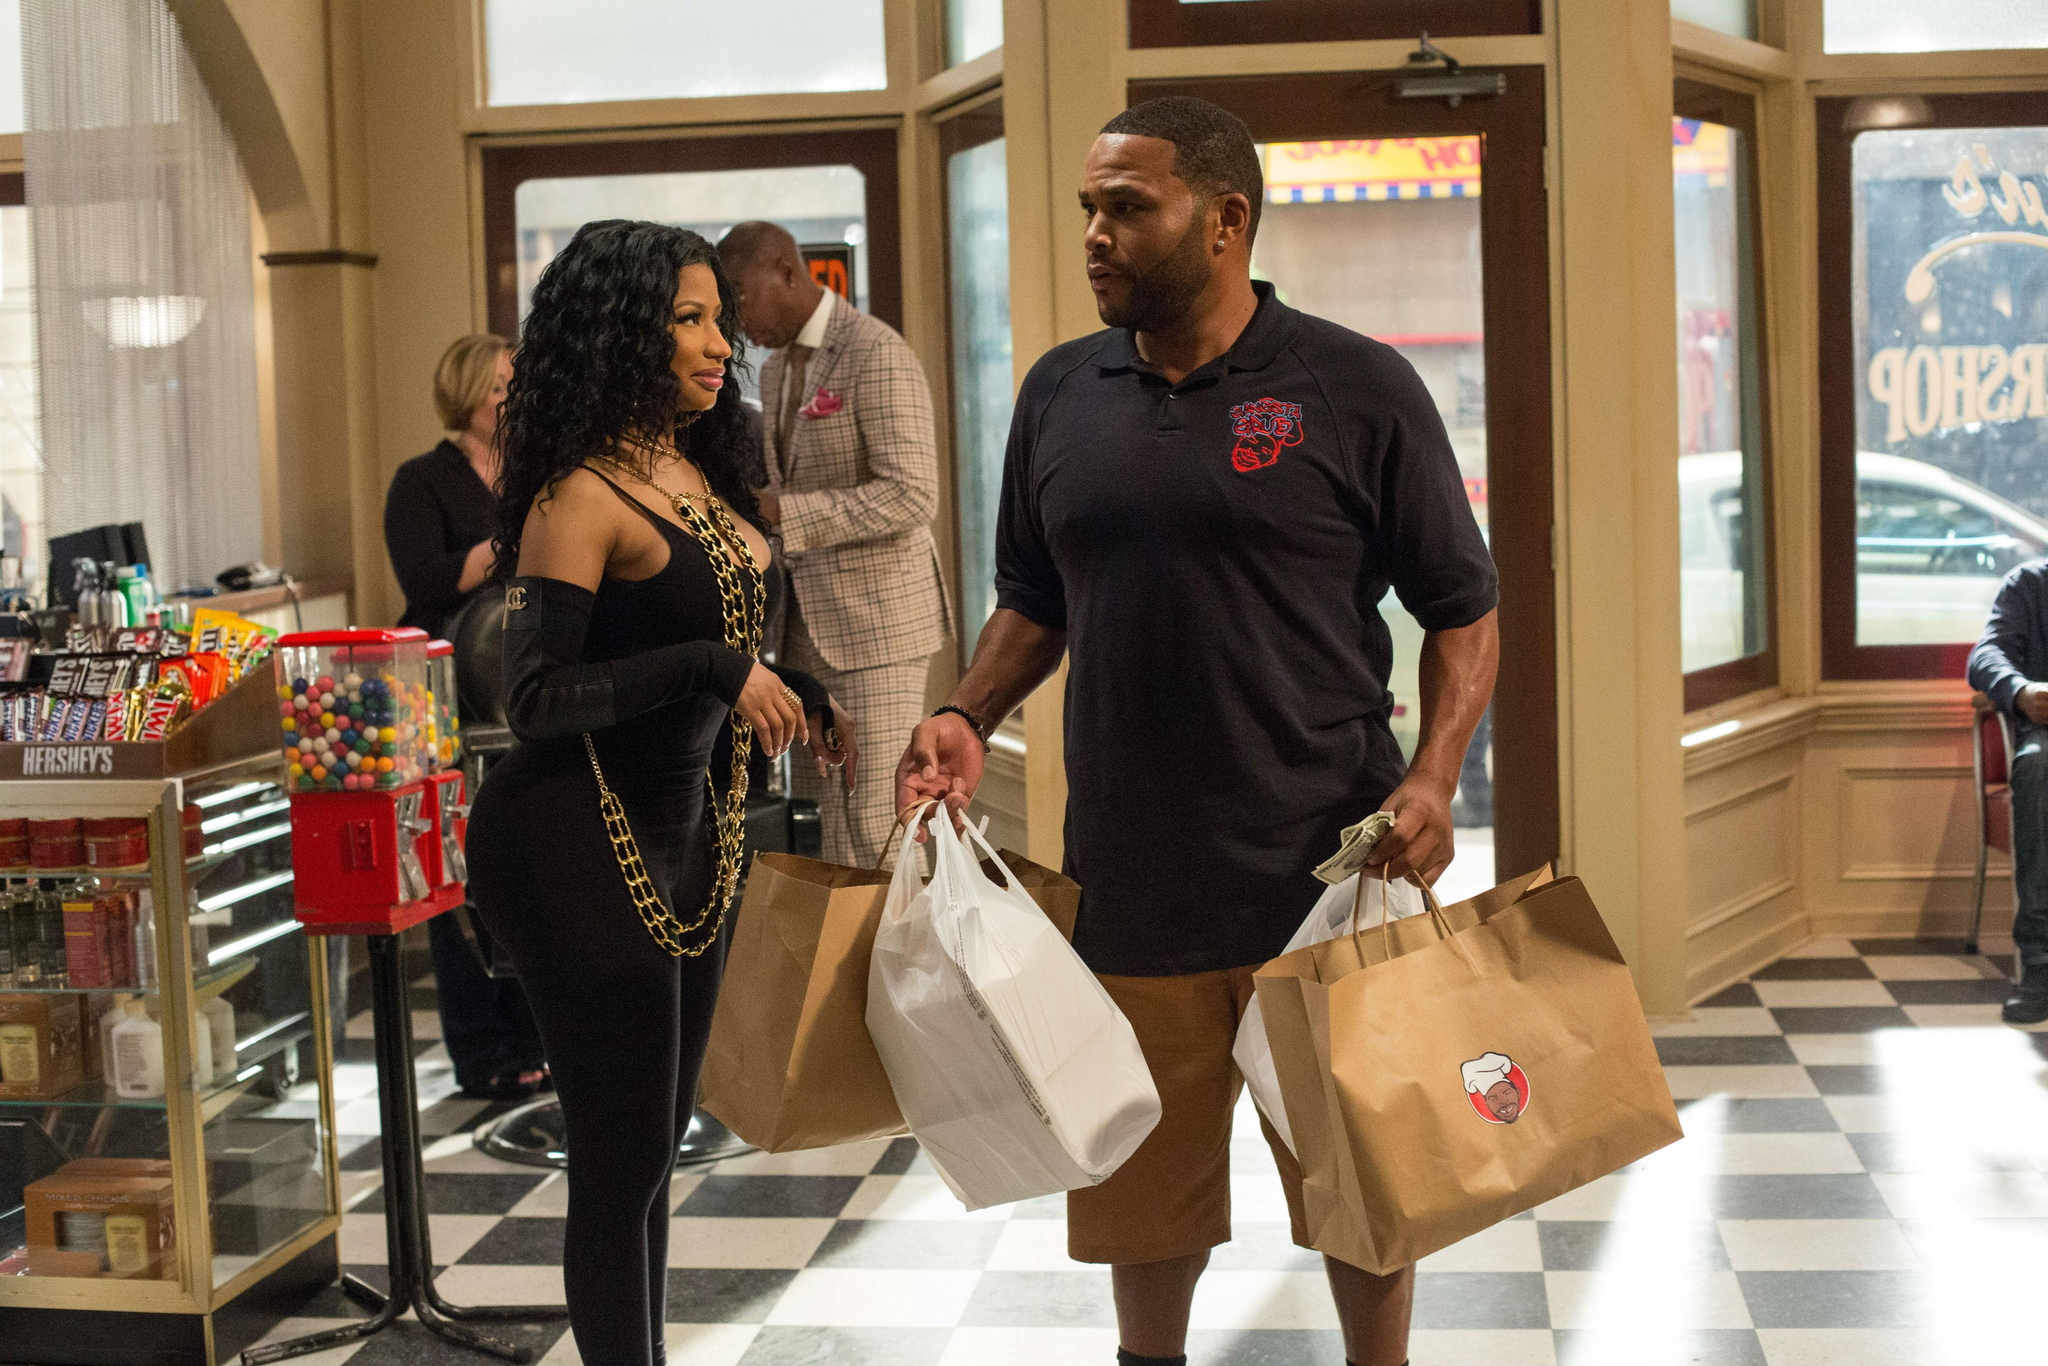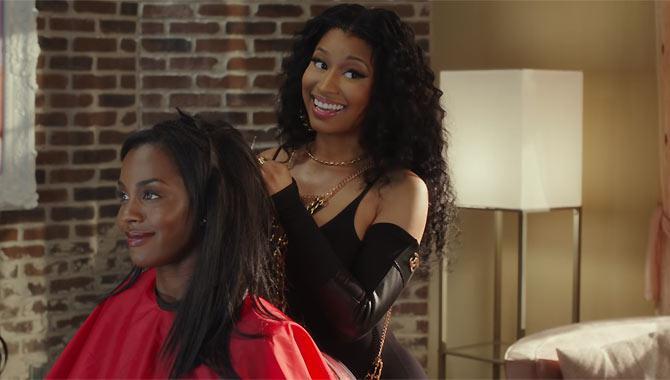The first image is the image on the left, the second image is the image on the right. Given the left and right images, does the statement "Nikki Minaj is NOT in the image on the right." hold true? Answer yes or no. No. 